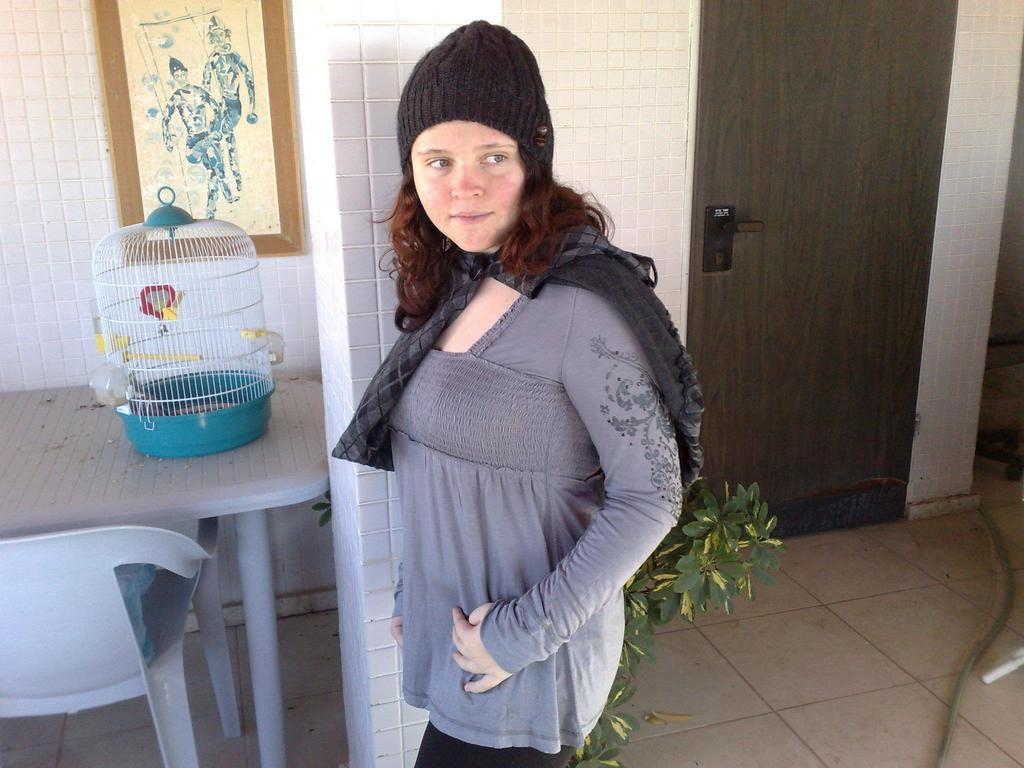Who is present in the image? There is a woman in the image. What object can be seen on a table in the image? There is a cage on a table in the image. What is the purpose of the door visible in the image? The door is likely used for entering or exiting a room or space. What can be seen in the background of the image? There is a wall in the background of the image. How does the woman self-level in the image? The woman does not self-level in the image; she is a person and not an object that requires leveling. 